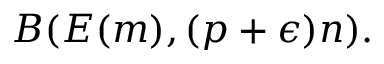<formula> <loc_0><loc_0><loc_500><loc_500>B ( E ( m ) , ( p + \epsilon ) n ) .</formula> 